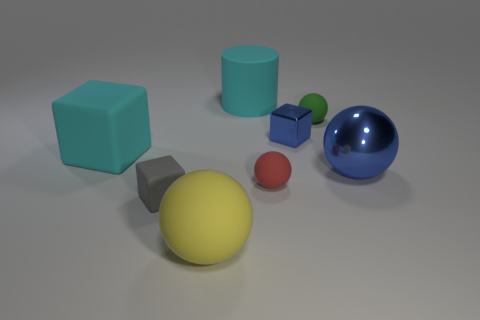What color is the cylinder that is made of the same material as the red sphere? The cylinder that shares the same material appearance as the red sphere is cyan, exhibiting a cool, calming hue reminiscent of clear sky or ocean water. 